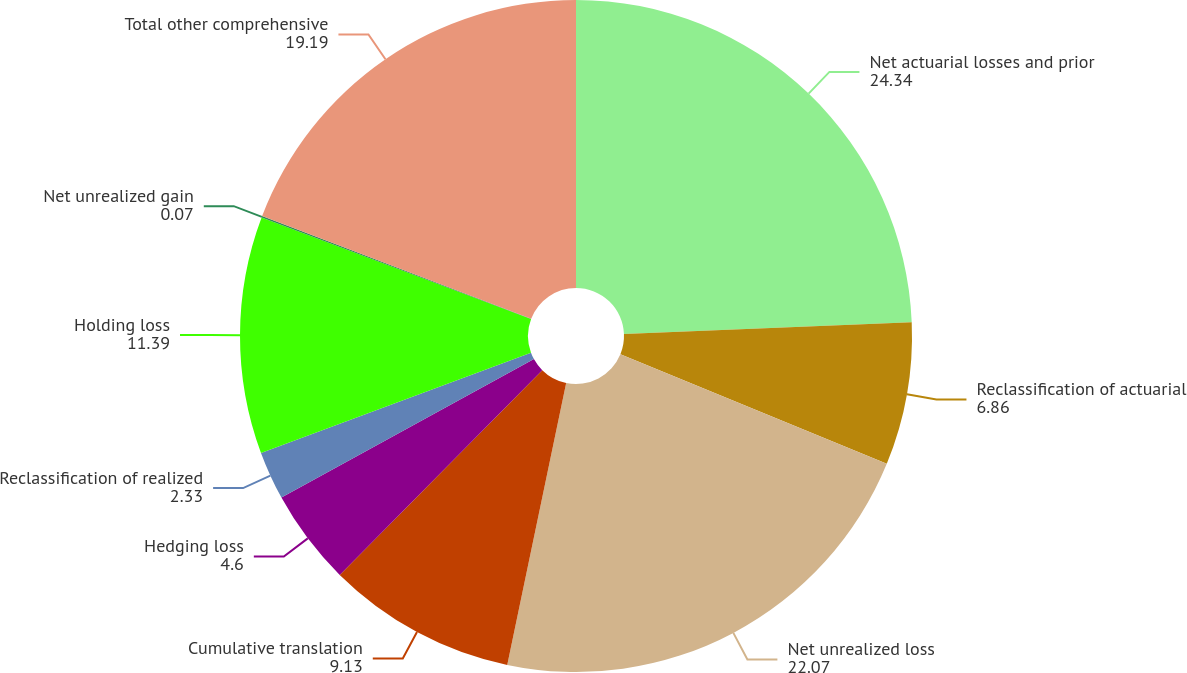Convert chart. <chart><loc_0><loc_0><loc_500><loc_500><pie_chart><fcel>Net actuarial losses and prior<fcel>Reclassification of actuarial<fcel>Net unrealized loss<fcel>Cumulative translation<fcel>Hedging loss<fcel>Reclassification of realized<fcel>Holding loss<fcel>Net unrealized gain<fcel>Total other comprehensive<nl><fcel>24.34%<fcel>6.86%<fcel>22.07%<fcel>9.13%<fcel>4.6%<fcel>2.33%<fcel>11.39%<fcel>0.07%<fcel>19.19%<nl></chart> 